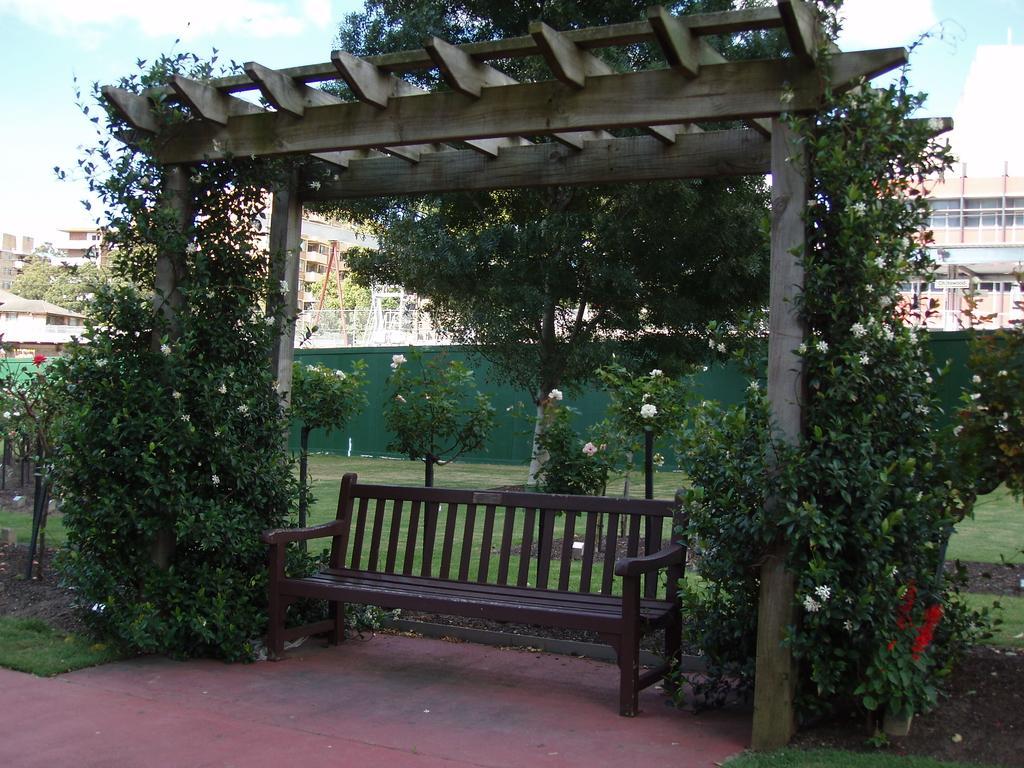How would you summarize this image in a sentence or two? In this image we can see some buildings in the background, few objects attached to the buildings, some objects in the background, one green wall, some trees, one bench, one wooden object with poles in the middle of the image, some plants with flowers, some objects on the ground, some grass on the ground and at the top there is the cloudy sky. 